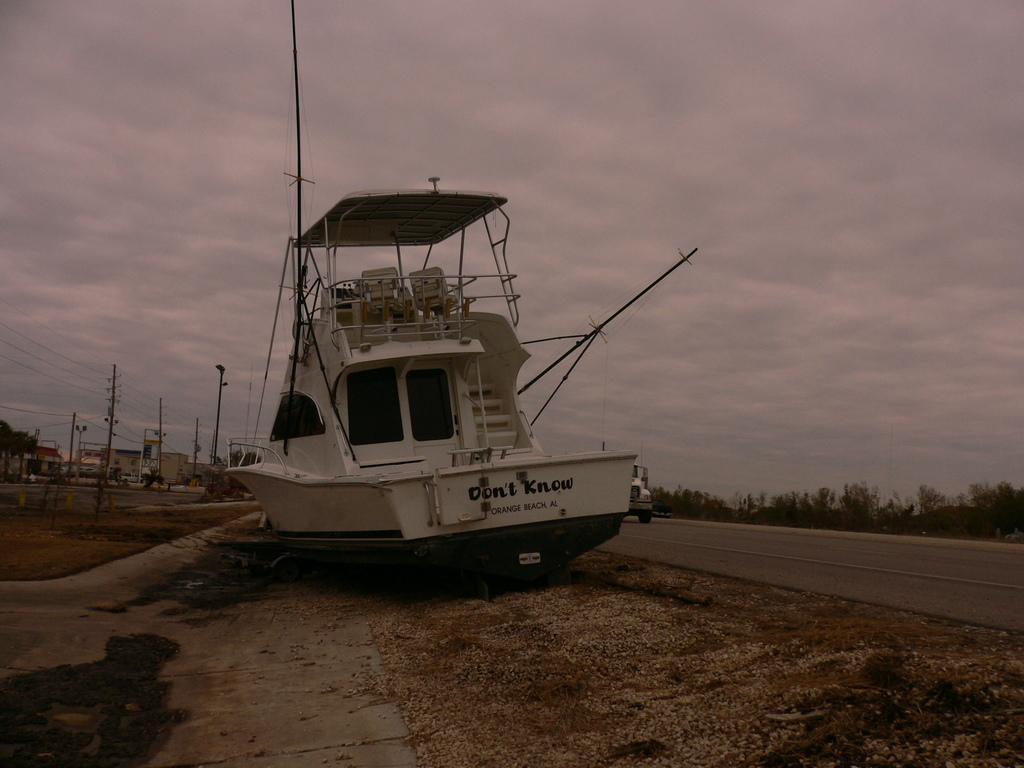Can you describe this image briefly? There is a boat on the side of the road. It is having windows, steps, railings and chairs. And something is written on that. On the side of the boat there is a road. In the back there are electric poles. Also there are trees in the background. And there is sky. 